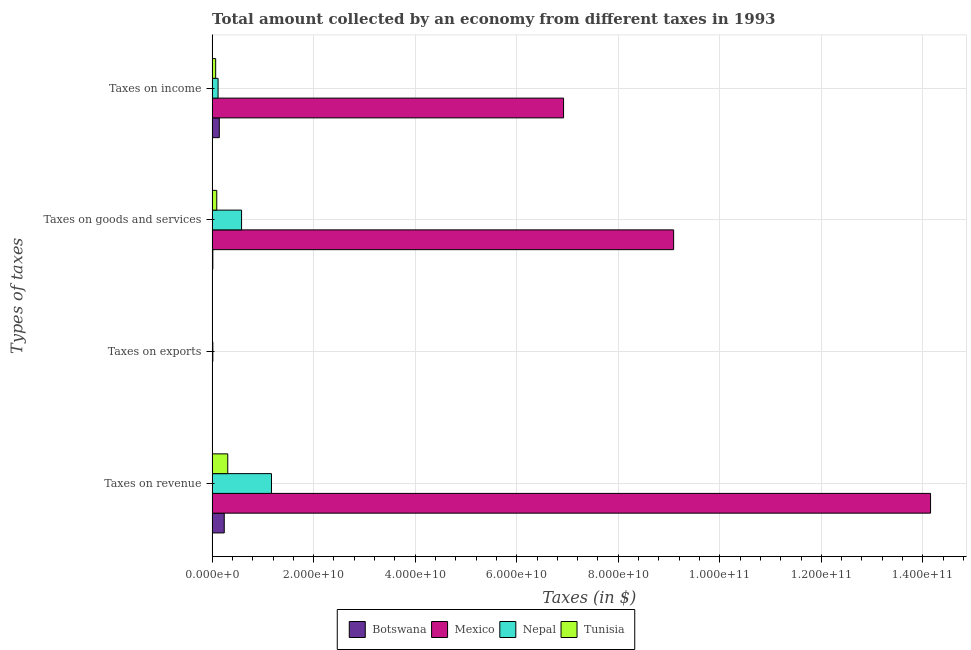How many groups of bars are there?
Ensure brevity in your answer.  4. What is the label of the 3rd group of bars from the top?
Give a very brief answer. Taxes on exports. What is the amount collected as tax on income in Mexico?
Keep it short and to the point. 6.92e+1. Across all countries, what is the maximum amount collected as tax on income?
Keep it short and to the point. 6.92e+1. Across all countries, what is the minimum amount collected as tax on income?
Your answer should be very brief. 6.98e+08. In which country was the amount collected as tax on exports maximum?
Ensure brevity in your answer.  Nepal. In which country was the amount collected as tax on revenue minimum?
Provide a succinct answer. Botswana. What is the total amount collected as tax on income in the graph?
Provide a succinct answer. 7.25e+1. What is the difference between the amount collected as tax on income in Mexico and that in Botswana?
Keep it short and to the point. 6.78e+1. What is the difference between the amount collected as tax on goods in Botswana and the amount collected as tax on income in Tunisia?
Give a very brief answer. -5.56e+08. What is the average amount collected as tax on goods per country?
Make the answer very short. 2.44e+1. What is the difference between the amount collected as tax on revenue and amount collected as tax on exports in Botswana?
Offer a very short reply. 2.39e+09. In how many countries, is the amount collected as tax on revenue greater than 100000000000 $?
Ensure brevity in your answer.  1. What is the ratio of the amount collected as tax on income in Botswana to that in Nepal?
Provide a short and direct response. 1.21. What is the difference between the highest and the second highest amount collected as tax on income?
Provide a short and direct response. 6.78e+1. What is the difference between the highest and the lowest amount collected as tax on income?
Keep it short and to the point. 6.85e+1. In how many countries, is the amount collected as tax on exports greater than the average amount collected as tax on exports taken over all countries?
Provide a succinct answer. 1. Is the sum of the amount collected as tax on revenue in Botswana and Tunisia greater than the maximum amount collected as tax on goods across all countries?
Provide a short and direct response. No. Is it the case that in every country, the sum of the amount collected as tax on goods and amount collected as tax on income is greater than the sum of amount collected as tax on revenue and amount collected as tax on exports?
Give a very brief answer. Yes. What does the 4th bar from the top in Taxes on income represents?
Your answer should be compact. Botswana. What does the 2nd bar from the bottom in Taxes on goods and services represents?
Make the answer very short. Mexico. Is it the case that in every country, the sum of the amount collected as tax on revenue and amount collected as tax on exports is greater than the amount collected as tax on goods?
Offer a terse response. Yes. Are all the bars in the graph horizontal?
Offer a very short reply. Yes. What is the difference between two consecutive major ticks on the X-axis?
Keep it short and to the point. 2.00e+1. Are the values on the major ticks of X-axis written in scientific E-notation?
Your response must be concise. Yes. Where does the legend appear in the graph?
Offer a very short reply. Bottom center. What is the title of the graph?
Offer a terse response. Total amount collected by an economy from different taxes in 1993. What is the label or title of the X-axis?
Your answer should be very brief. Taxes (in $). What is the label or title of the Y-axis?
Offer a terse response. Types of taxes. What is the Taxes (in $) in Botswana in Taxes on revenue?
Offer a very short reply. 2.39e+09. What is the Taxes (in $) in Mexico in Taxes on revenue?
Keep it short and to the point. 1.42e+11. What is the Taxes (in $) in Nepal in Taxes on revenue?
Give a very brief answer. 1.17e+1. What is the Taxes (in $) in Tunisia in Taxes on revenue?
Your response must be concise. 3.08e+09. What is the Taxes (in $) of Botswana in Taxes on exports?
Offer a very short reply. 5.00e+05. What is the Taxes (in $) in Mexico in Taxes on exports?
Make the answer very short. 3.10e+07. What is the Taxes (in $) of Nepal in Taxes on exports?
Provide a succinct answer. 1.41e+08. What is the Taxes (in $) in Tunisia in Taxes on exports?
Your answer should be very brief. 9.10e+06. What is the Taxes (in $) of Botswana in Taxes on goods and services?
Provide a succinct answer. 1.42e+08. What is the Taxes (in $) in Mexico in Taxes on goods and services?
Your response must be concise. 9.09e+1. What is the Taxes (in $) in Nepal in Taxes on goods and services?
Keep it short and to the point. 5.80e+09. What is the Taxes (in $) of Tunisia in Taxes on goods and services?
Your response must be concise. 9.14e+08. What is the Taxes (in $) of Botswana in Taxes on income?
Offer a very short reply. 1.42e+09. What is the Taxes (in $) in Mexico in Taxes on income?
Make the answer very short. 6.92e+1. What is the Taxes (in $) in Nepal in Taxes on income?
Ensure brevity in your answer.  1.17e+09. What is the Taxes (in $) in Tunisia in Taxes on income?
Your answer should be compact. 6.98e+08. Across all Types of taxes, what is the maximum Taxes (in $) in Botswana?
Provide a succinct answer. 2.39e+09. Across all Types of taxes, what is the maximum Taxes (in $) of Mexico?
Your answer should be very brief. 1.42e+11. Across all Types of taxes, what is the maximum Taxes (in $) in Nepal?
Offer a very short reply. 1.17e+1. Across all Types of taxes, what is the maximum Taxes (in $) of Tunisia?
Offer a terse response. 3.08e+09. Across all Types of taxes, what is the minimum Taxes (in $) in Mexico?
Provide a succinct answer. 3.10e+07. Across all Types of taxes, what is the minimum Taxes (in $) of Nepal?
Your answer should be very brief. 1.41e+08. Across all Types of taxes, what is the minimum Taxes (in $) in Tunisia?
Your answer should be compact. 9.10e+06. What is the total Taxes (in $) of Botswana in the graph?
Your response must be concise. 3.95e+09. What is the total Taxes (in $) in Mexico in the graph?
Make the answer very short. 3.02e+11. What is the total Taxes (in $) of Nepal in the graph?
Give a very brief answer. 1.88e+1. What is the total Taxes (in $) in Tunisia in the graph?
Your answer should be compact. 4.70e+09. What is the difference between the Taxes (in $) of Botswana in Taxes on revenue and that in Taxes on exports?
Your answer should be compact. 2.39e+09. What is the difference between the Taxes (in $) in Mexico in Taxes on revenue and that in Taxes on exports?
Your answer should be very brief. 1.41e+11. What is the difference between the Taxes (in $) of Nepal in Taxes on revenue and that in Taxes on exports?
Your answer should be compact. 1.16e+1. What is the difference between the Taxes (in $) in Tunisia in Taxes on revenue and that in Taxes on exports?
Provide a succinct answer. 3.07e+09. What is the difference between the Taxes (in $) in Botswana in Taxes on revenue and that in Taxes on goods and services?
Offer a very short reply. 2.25e+09. What is the difference between the Taxes (in $) in Mexico in Taxes on revenue and that in Taxes on goods and services?
Provide a succinct answer. 5.06e+1. What is the difference between the Taxes (in $) in Nepal in Taxes on revenue and that in Taxes on goods and services?
Offer a very short reply. 5.89e+09. What is the difference between the Taxes (in $) in Tunisia in Taxes on revenue and that in Taxes on goods and services?
Provide a short and direct response. 2.17e+09. What is the difference between the Taxes (in $) of Botswana in Taxes on revenue and that in Taxes on income?
Provide a succinct answer. 9.72e+08. What is the difference between the Taxes (in $) of Mexico in Taxes on revenue and that in Taxes on income?
Your answer should be very brief. 7.23e+1. What is the difference between the Taxes (in $) in Nepal in Taxes on revenue and that in Taxes on income?
Give a very brief answer. 1.05e+1. What is the difference between the Taxes (in $) of Tunisia in Taxes on revenue and that in Taxes on income?
Your answer should be very brief. 2.38e+09. What is the difference between the Taxes (in $) in Botswana in Taxes on exports and that in Taxes on goods and services?
Make the answer very short. -1.42e+08. What is the difference between the Taxes (in $) in Mexico in Taxes on exports and that in Taxes on goods and services?
Offer a very short reply. -9.09e+1. What is the difference between the Taxes (in $) of Nepal in Taxes on exports and that in Taxes on goods and services?
Make the answer very short. -5.66e+09. What is the difference between the Taxes (in $) in Tunisia in Taxes on exports and that in Taxes on goods and services?
Your response must be concise. -9.04e+08. What is the difference between the Taxes (in $) in Botswana in Taxes on exports and that in Taxes on income?
Give a very brief answer. -1.41e+09. What is the difference between the Taxes (in $) of Mexico in Taxes on exports and that in Taxes on income?
Offer a terse response. -6.92e+1. What is the difference between the Taxes (in $) in Nepal in Taxes on exports and that in Taxes on income?
Give a very brief answer. -1.03e+09. What is the difference between the Taxes (in $) of Tunisia in Taxes on exports and that in Taxes on income?
Your answer should be very brief. -6.89e+08. What is the difference between the Taxes (in $) of Botswana in Taxes on goods and services and that in Taxes on income?
Your answer should be compact. -1.27e+09. What is the difference between the Taxes (in $) of Mexico in Taxes on goods and services and that in Taxes on income?
Your answer should be compact. 2.17e+1. What is the difference between the Taxes (in $) of Nepal in Taxes on goods and services and that in Taxes on income?
Your answer should be very brief. 4.63e+09. What is the difference between the Taxes (in $) of Tunisia in Taxes on goods and services and that in Taxes on income?
Keep it short and to the point. 2.15e+08. What is the difference between the Taxes (in $) in Botswana in Taxes on revenue and the Taxes (in $) in Mexico in Taxes on exports?
Your response must be concise. 2.36e+09. What is the difference between the Taxes (in $) in Botswana in Taxes on revenue and the Taxes (in $) in Nepal in Taxes on exports?
Provide a succinct answer. 2.25e+09. What is the difference between the Taxes (in $) in Botswana in Taxes on revenue and the Taxes (in $) in Tunisia in Taxes on exports?
Make the answer very short. 2.38e+09. What is the difference between the Taxes (in $) in Mexico in Taxes on revenue and the Taxes (in $) in Nepal in Taxes on exports?
Provide a short and direct response. 1.41e+11. What is the difference between the Taxes (in $) in Mexico in Taxes on revenue and the Taxes (in $) in Tunisia in Taxes on exports?
Offer a very short reply. 1.42e+11. What is the difference between the Taxes (in $) in Nepal in Taxes on revenue and the Taxes (in $) in Tunisia in Taxes on exports?
Your answer should be compact. 1.17e+1. What is the difference between the Taxes (in $) in Botswana in Taxes on revenue and the Taxes (in $) in Mexico in Taxes on goods and services?
Your answer should be compact. -8.85e+1. What is the difference between the Taxes (in $) in Botswana in Taxes on revenue and the Taxes (in $) in Nepal in Taxes on goods and services?
Your answer should be very brief. -3.41e+09. What is the difference between the Taxes (in $) of Botswana in Taxes on revenue and the Taxes (in $) of Tunisia in Taxes on goods and services?
Give a very brief answer. 1.47e+09. What is the difference between the Taxes (in $) in Mexico in Taxes on revenue and the Taxes (in $) in Nepal in Taxes on goods and services?
Make the answer very short. 1.36e+11. What is the difference between the Taxes (in $) of Mexico in Taxes on revenue and the Taxes (in $) of Tunisia in Taxes on goods and services?
Give a very brief answer. 1.41e+11. What is the difference between the Taxes (in $) in Nepal in Taxes on revenue and the Taxes (in $) in Tunisia in Taxes on goods and services?
Offer a terse response. 1.08e+1. What is the difference between the Taxes (in $) in Botswana in Taxes on revenue and the Taxes (in $) in Mexico in Taxes on income?
Ensure brevity in your answer.  -6.68e+1. What is the difference between the Taxes (in $) of Botswana in Taxes on revenue and the Taxes (in $) of Nepal in Taxes on income?
Your answer should be very brief. 1.21e+09. What is the difference between the Taxes (in $) in Botswana in Taxes on revenue and the Taxes (in $) in Tunisia in Taxes on income?
Give a very brief answer. 1.69e+09. What is the difference between the Taxes (in $) in Mexico in Taxes on revenue and the Taxes (in $) in Nepal in Taxes on income?
Make the answer very short. 1.40e+11. What is the difference between the Taxes (in $) of Mexico in Taxes on revenue and the Taxes (in $) of Tunisia in Taxes on income?
Your answer should be very brief. 1.41e+11. What is the difference between the Taxes (in $) in Nepal in Taxes on revenue and the Taxes (in $) in Tunisia in Taxes on income?
Offer a very short reply. 1.10e+1. What is the difference between the Taxes (in $) of Botswana in Taxes on exports and the Taxes (in $) of Mexico in Taxes on goods and services?
Your answer should be very brief. -9.09e+1. What is the difference between the Taxes (in $) in Botswana in Taxes on exports and the Taxes (in $) in Nepal in Taxes on goods and services?
Provide a succinct answer. -5.80e+09. What is the difference between the Taxes (in $) of Botswana in Taxes on exports and the Taxes (in $) of Tunisia in Taxes on goods and services?
Offer a terse response. -9.13e+08. What is the difference between the Taxes (in $) in Mexico in Taxes on exports and the Taxes (in $) in Nepal in Taxes on goods and services?
Your answer should be very brief. -5.77e+09. What is the difference between the Taxes (in $) of Mexico in Taxes on exports and the Taxes (in $) of Tunisia in Taxes on goods and services?
Make the answer very short. -8.82e+08. What is the difference between the Taxes (in $) in Nepal in Taxes on exports and the Taxes (in $) in Tunisia in Taxes on goods and services?
Your answer should be very brief. -7.72e+08. What is the difference between the Taxes (in $) of Botswana in Taxes on exports and the Taxes (in $) of Mexico in Taxes on income?
Make the answer very short. -6.92e+1. What is the difference between the Taxes (in $) of Botswana in Taxes on exports and the Taxes (in $) of Nepal in Taxes on income?
Provide a short and direct response. -1.17e+09. What is the difference between the Taxes (in $) in Botswana in Taxes on exports and the Taxes (in $) in Tunisia in Taxes on income?
Ensure brevity in your answer.  -6.98e+08. What is the difference between the Taxes (in $) in Mexico in Taxes on exports and the Taxes (in $) in Nepal in Taxes on income?
Your response must be concise. -1.14e+09. What is the difference between the Taxes (in $) of Mexico in Taxes on exports and the Taxes (in $) of Tunisia in Taxes on income?
Provide a short and direct response. -6.67e+08. What is the difference between the Taxes (in $) in Nepal in Taxes on exports and the Taxes (in $) in Tunisia in Taxes on income?
Ensure brevity in your answer.  -5.57e+08. What is the difference between the Taxes (in $) of Botswana in Taxes on goods and services and the Taxes (in $) of Mexico in Taxes on income?
Provide a succinct answer. -6.91e+1. What is the difference between the Taxes (in $) in Botswana in Taxes on goods and services and the Taxes (in $) in Nepal in Taxes on income?
Give a very brief answer. -1.03e+09. What is the difference between the Taxes (in $) of Botswana in Taxes on goods and services and the Taxes (in $) of Tunisia in Taxes on income?
Ensure brevity in your answer.  -5.56e+08. What is the difference between the Taxes (in $) in Mexico in Taxes on goods and services and the Taxes (in $) in Nepal in Taxes on income?
Offer a very short reply. 8.97e+1. What is the difference between the Taxes (in $) in Mexico in Taxes on goods and services and the Taxes (in $) in Tunisia in Taxes on income?
Provide a short and direct response. 9.02e+1. What is the difference between the Taxes (in $) in Nepal in Taxes on goods and services and the Taxes (in $) in Tunisia in Taxes on income?
Give a very brief answer. 5.10e+09. What is the average Taxes (in $) in Botswana per Types of taxes?
Make the answer very short. 9.86e+08. What is the average Taxes (in $) of Mexico per Types of taxes?
Make the answer very short. 7.54e+1. What is the average Taxes (in $) of Nepal per Types of taxes?
Offer a very short reply. 4.70e+09. What is the average Taxes (in $) in Tunisia per Types of taxes?
Your answer should be very brief. 1.18e+09. What is the difference between the Taxes (in $) of Botswana and Taxes (in $) of Mexico in Taxes on revenue?
Your answer should be compact. -1.39e+11. What is the difference between the Taxes (in $) in Botswana and Taxes (in $) in Nepal in Taxes on revenue?
Offer a very short reply. -9.30e+09. What is the difference between the Taxes (in $) of Botswana and Taxes (in $) of Tunisia in Taxes on revenue?
Provide a short and direct response. -6.93e+08. What is the difference between the Taxes (in $) of Mexico and Taxes (in $) of Nepal in Taxes on revenue?
Your answer should be very brief. 1.30e+11. What is the difference between the Taxes (in $) in Mexico and Taxes (in $) in Tunisia in Taxes on revenue?
Offer a very short reply. 1.38e+11. What is the difference between the Taxes (in $) in Nepal and Taxes (in $) in Tunisia in Taxes on revenue?
Offer a terse response. 8.61e+09. What is the difference between the Taxes (in $) in Botswana and Taxes (in $) in Mexico in Taxes on exports?
Ensure brevity in your answer.  -3.05e+07. What is the difference between the Taxes (in $) of Botswana and Taxes (in $) of Nepal in Taxes on exports?
Your answer should be compact. -1.40e+08. What is the difference between the Taxes (in $) in Botswana and Taxes (in $) in Tunisia in Taxes on exports?
Your response must be concise. -8.60e+06. What is the difference between the Taxes (in $) in Mexico and Taxes (in $) in Nepal in Taxes on exports?
Make the answer very short. -1.10e+08. What is the difference between the Taxes (in $) of Mexico and Taxes (in $) of Tunisia in Taxes on exports?
Give a very brief answer. 2.19e+07. What is the difference between the Taxes (in $) of Nepal and Taxes (in $) of Tunisia in Taxes on exports?
Give a very brief answer. 1.32e+08. What is the difference between the Taxes (in $) of Botswana and Taxes (in $) of Mexico in Taxes on goods and services?
Offer a very short reply. -9.08e+1. What is the difference between the Taxes (in $) of Botswana and Taxes (in $) of Nepal in Taxes on goods and services?
Your response must be concise. -5.66e+09. What is the difference between the Taxes (in $) in Botswana and Taxes (in $) in Tunisia in Taxes on goods and services?
Give a very brief answer. -7.71e+08. What is the difference between the Taxes (in $) of Mexico and Taxes (in $) of Nepal in Taxes on goods and services?
Give a very brief answer. 8.51e+1. What is the difference between the Taxes (in $) in Mexico and Taxes (in $) in Tunisia in Taxes on goods and services?
Give a very brief answer. 9.00e+1. What is the difference between the Taxes (in $) in Nepal and Taxes (in $) in Tunisia in Taxes on goods and services?
Give a very brief answer. 4.89e+09. What is the difference between the Taxes (in $) in Botswana and Taxes (in $) in Mexico in Taxes on income?
Make the answer very short. -6.78e+1. What is the difference between the Taxes (in $) of Botswana and Taxes (in $) of Nepal in Taxes on income?
Your answer should be very brief. 2.41e+08. What is the difference between the Taxes (in $) of Botswana and Taxes (in $) of Tunisia in Taxes on income?
Offer a terse response. 7.17e+08. What is the difference between the Taxes (in $) of Mexico and Taxes (in $) of Nepal in Taxes on income?
Provide a succinct answer. 6.80e+1. What is the difference between the Taxes (in $) in Mexico and Taxes (in $) in Tunisia in Taxes on income?
Keep it short and to the point. 6.85e+1. What is the difference between the Taxes (in $) in Nepal and Taxes (in $) in Tunisia in Taxes on income?
Offer a very short reply. 4.76e+08. What is the ratio of the Taxes (in $) of Botswana in Taxes on revenue to that in Taxes on exports?
Offer a terse response. 4775. What is the ratio of the Taxes (in $) in Mexico in Taxes on revenue to that in Taxes on exports?
Provide a short and direct response. 4564.84. What is the ratio of the Taxes (in $) of Nepal in Taxes on revenue to that in Taxes on exports?
Provide a succinct answer. 82.91. What is the ratio of the Taxes (in $) in Tunisia in Taxes on revenue to that in Taxes on exports?
Make the answer very short. 338.51. What is the ratio of the Taxes (in $) in Botswana in Taxes on revenue to that in Taxes on goods and services?
Provide a succinct answer. 16.77. What is the ratio of the Taxes (in $) in Mexico in Taxes on revenue to that in Taxes on goods and services?
Ensure brevity in your answer.  1.56. What is the ratio of the Taxes (in $) in Nepal in Taxes on revenue to that in Taxes on goods and services?
Give a very brief answer. 2.02. What is the ratio of the Taxes (in $) in Tunisia in Taxes on revenue to that in Taxes on goods and services?
Give a very brief answer. 3.37. What is the ratio of the Taxes (in $) of Botswana in Taxes on revenue to that in Taxes on income?
Make the answer very short. 1.69. What is the ratio of the Taxes (in $) of Mexico in Taxes on revenue to that in Taxes on income?
Provide a succinct answer. 2.04. What is the ratio of the Taxes (in $) of Nepal in Taxes on revenue to that in Taxes on income?
Offer a terse response. 9.96. What is the ratio of the Taxes (in $) of Tunisia in Taxes on revenue to that in Taxes on income?
Provide a short and direct response. 4.41. What is the ratio of the Taxes (in $) of Botswana in Taxes on exports to that in Taxes on goods and services?
Provide a short and direct response. 0. What is the ratio of the Taxes (in $) of Nepal in Taxes on exports to that in Taxes on goods and services?
Offer a very short reply. 0.02. What is the ratio of the Taxes (in $) in Tunisia in Taxes on exports to that in Taxes on goods and services?
Your answer should be very brief. 0.01. What is the ratio of the Taxes (in $) in Nepal in Taxes on exports to that in Taxes on income?
Provide a succinct answer. 0.12. What is the ratio of the Taxes (in $) in Tunisia in Taxes on exports to that in Taxes on income?
Provide a succinct answer. 0.01. What is the ratio of the Taxes (in $) in Botswana in Taxes on goods and services to that in Taxes on income?
Offer a very short reply. 0.1. What is the ratio of the Taxes (in $) in Mexico in Taxes on goods and services to that in Taxes on income?
Offer a very short reply. 1.31. What is the ratio of the Taxes (in $) in Nepal in Taxes on goods and services to that in Taxes on income?
Your answer should be compact. 4.94. What is the ratio of the Taxes (in $) in Tunisia in Taxes on goods and services to that in Taxes on income?
Your response must be concise. 1.31. What is the difference between the highest and the second highest Taxes (in $) of Botswana?
Your answer should be compact. 9.72e+08. What is the difference between the highest and the second highest Taxes (in $) of Mexico?
Give a very brief answer. 5.06e+1. What is the difference between the highest and the second highest Taxes (in $) of Nepal?
Provide a short and direct response. 5.89e+09. What is the difference between the highest and the second highest Taxes (in $) of Tunisia?
Your response must be concise. 2.17e+09. What is the difference between the highest and the lowest Taxes (in $) in Botswana?
Offer a very short reply. 2.39e+09. What is the difference between the highest and the lowest Taxes (in $) of Mexico?
Keep it short and to the point. 1.41e+11. What is the difference between the highest and the lowest Taxes (in $) in Nepal?
Keep it short and to the point. 1.16e+1. What is the difference between the highest and the lowest Taxes (in $) of Tunisia?
Provide a succinct answer. 3.07e+09. 